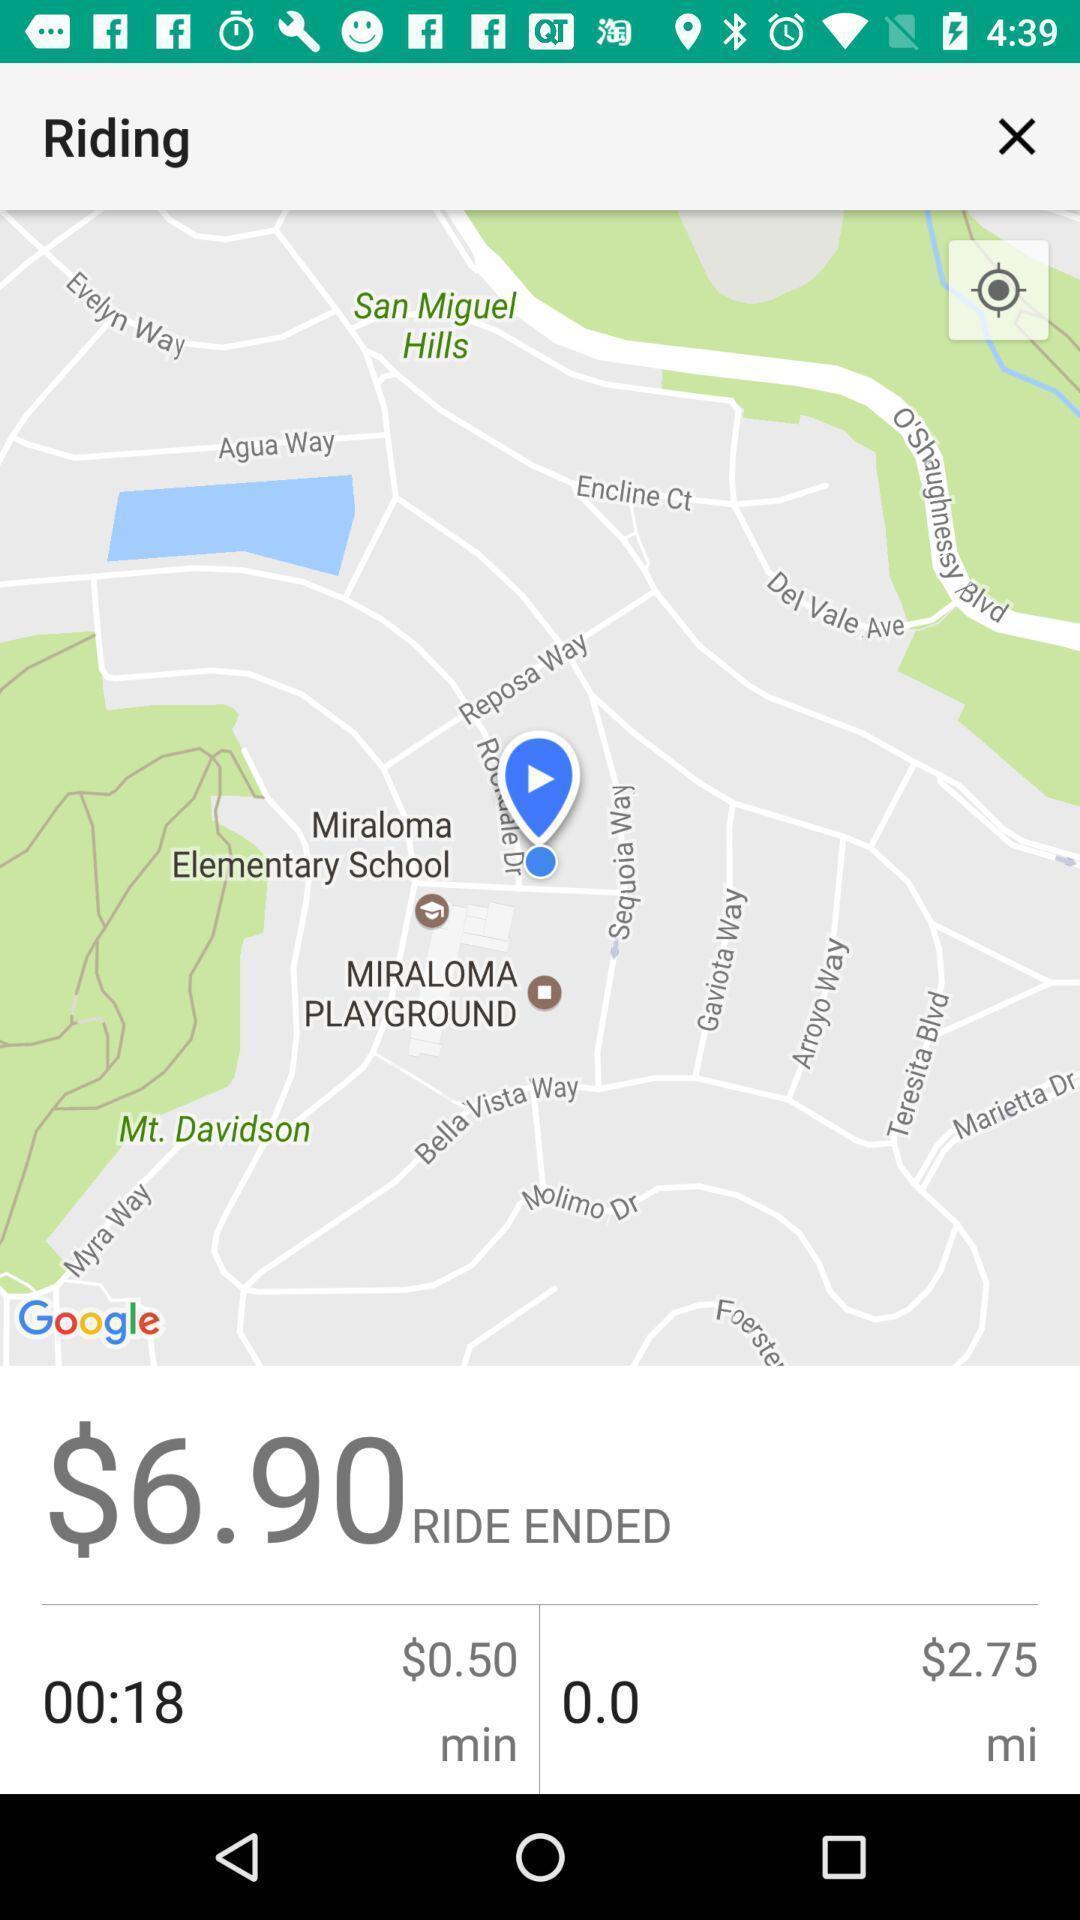Describe this image in words. Screen shows riding details with map view. 